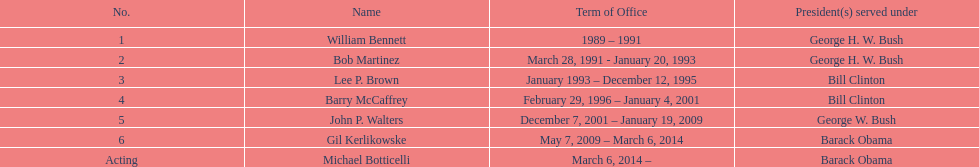What was the quantity of directors with a tenure exceeding three years? 3. Can you give me this table as a dict? {'header': ['No.', 'Name', 'Term of Office', 'President(s) served under'], 'rows': [['1', 'William Bennett', '1989 – 1991', 'George H. W. Bush'], ['2', 'Bob Martinez', 'March 28, 1991 - January 20, 1993', 'George H. W. Bush'], ['3', 'Lee P. Brown', 'January 1993 – December 12, 1995', 'Bill Clinton'], ['4', 'Barry McCaffrey', 'February 29, 1996 – January 4, 2001', 'Bill Clinton'], ['5', 'John P. Walters', 'December 7, 2001 – January 19, 2009', 'George W. Bush'], ['6', 'Gil Kerlikowske', 'May 7, 2009 – March 6, 2014', 'Barack Obama'], ['Acting', 'Michael Botticelli', 'March 6, 2014 –', 'Barack Obama']]} 